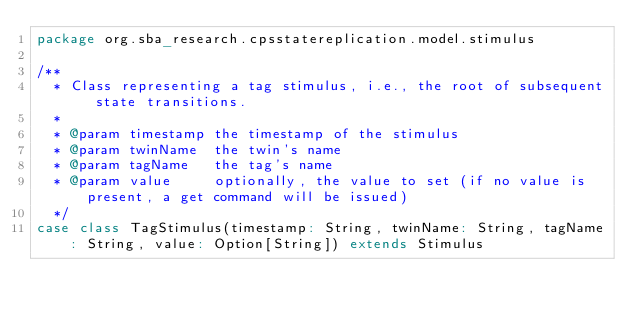<code> <loc_0><loc_0><loc_500><loc_500><_Scala_>package org.sba_research.cpsstatereplication.model.stimulus

/**
  * Class representing a tag stimulus, i.e., the root of subsequent state transitions.
  *
  * @param timestamp the timestamp of the stimulus
  * @param twinName  the twin's name
  * @param tagName   the tag's name
  * @param value     optionally, the value to set (if no value is present, a get command will be issued)
  */
case class TagStimulus(timestamp: String, twinName: String, tagName: String, value: Option[String]) extends Stimulus
</code> 